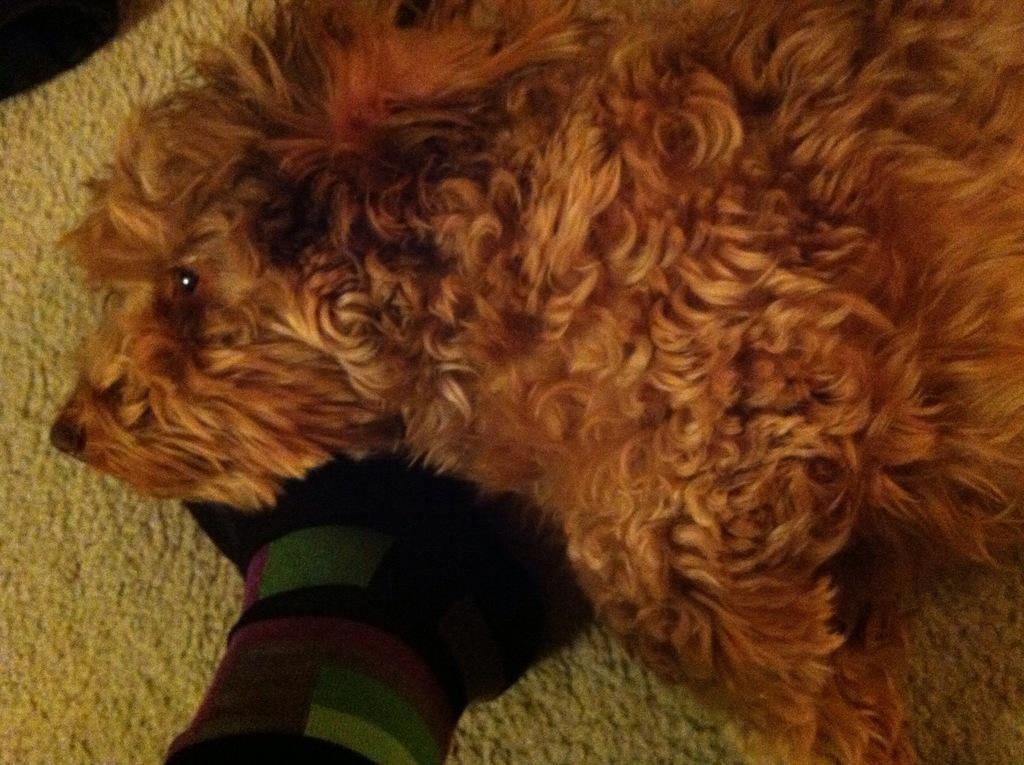Could you give a brief overview of what you see in this image? In this picture we can see a dog, it looks like a floor mat at the bottom. 